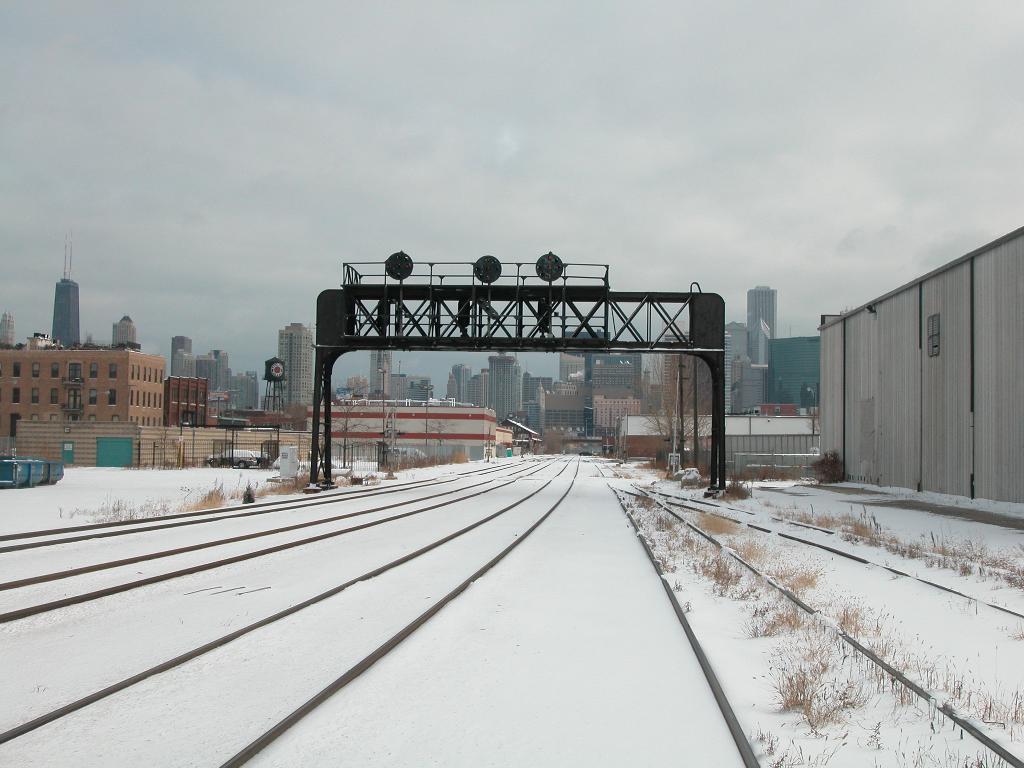Can you describe this image briefly? In this image, we can see the ground covered with snow, some objects and grass. We can see some railway tracks. We can also see the metallic arch. There are a few buildings and poles. We can also see an object on the right. We can see the sky with clouds. 